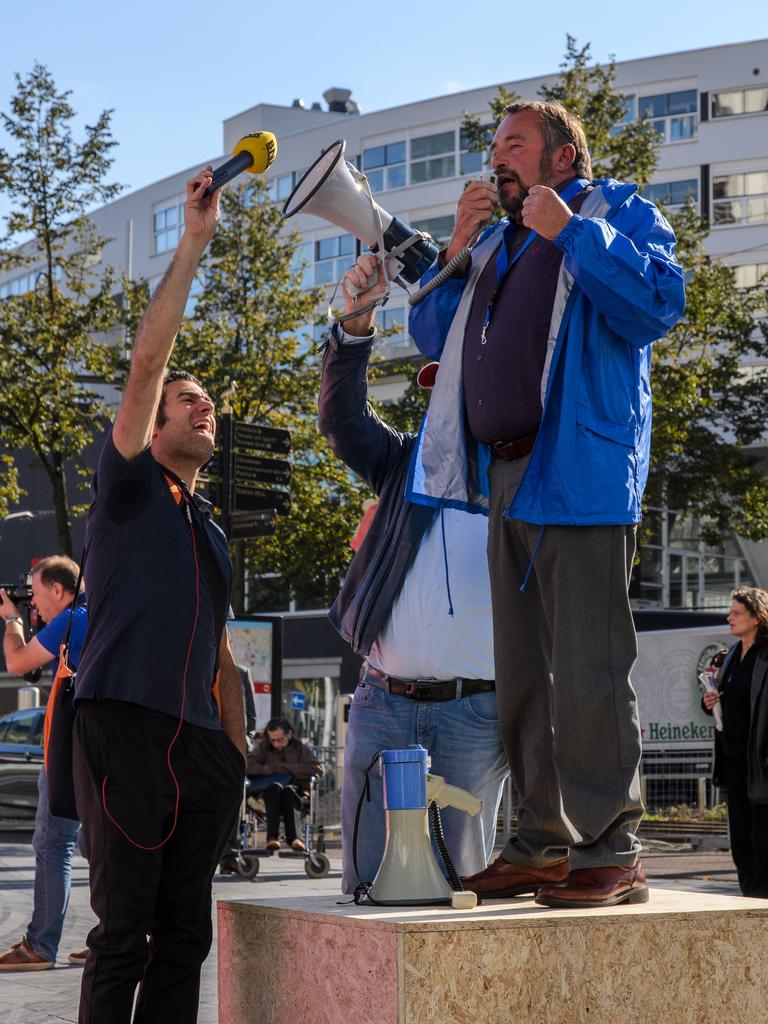How many persons are in the image? There are persons in the image. What are the persons holding in the image? One person is holding a microphone, and another person is holding a speaker. What type of natural vegetation is present in the image? There are trees in the image. What type of man-made structures are present in the image? There are boards and a building in the image. What is visible in the background of the image? The sky is visible in the background of the image. What type of stem can be seen growing from the seashore in the image? There is no seashore or stem present in the image. 